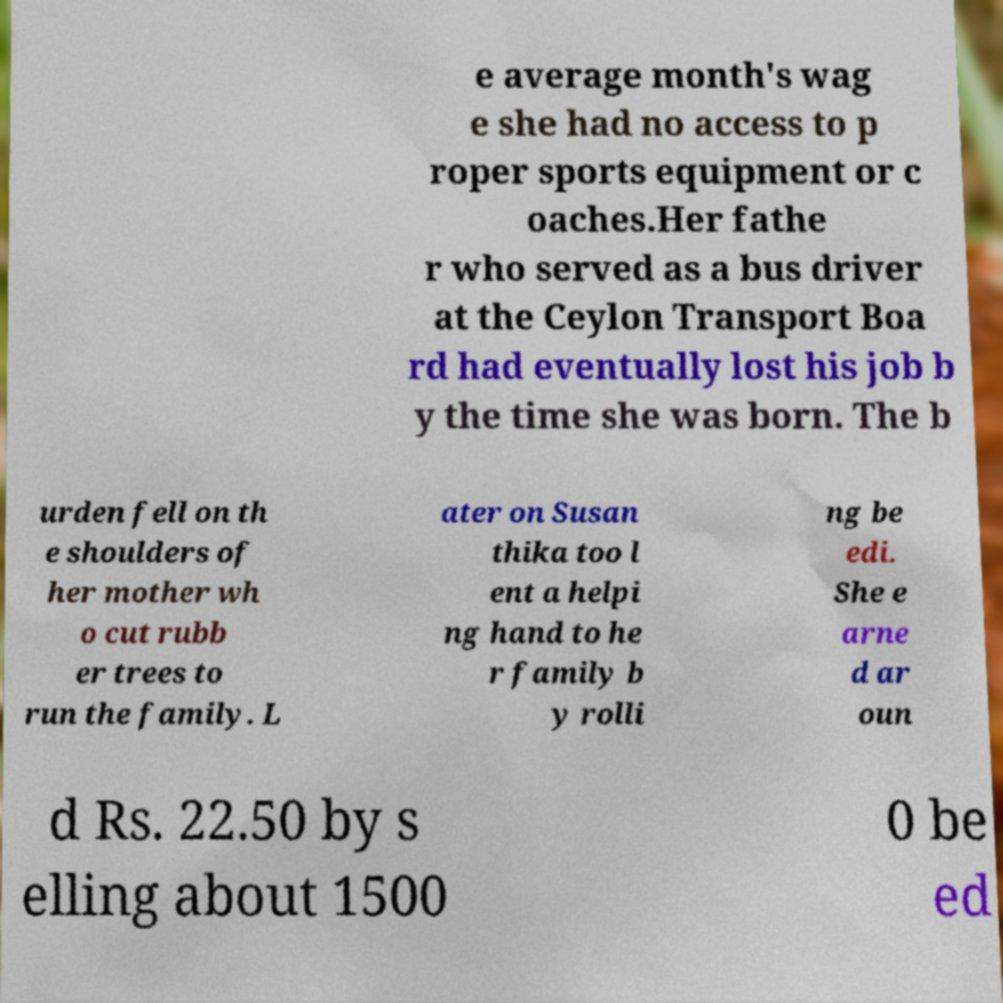Could you extract and type out the text from this image? e average month's wag e she had no access to p roper sports equipment or c oaches.Her fathe r who served as a bus driver at the Ceylon Transport Boa rd had eventually lost his job b y the time she was born. The b urden fell on th e shoulders of her mother wh o cut rubb er trees to run the family. L ater on Susan thika too l ent a helpi ng hand to he r family b y rolli ng be edi. She e arne d ar oun d Rs. 22.50 by s elling about 1500 0 be ed 